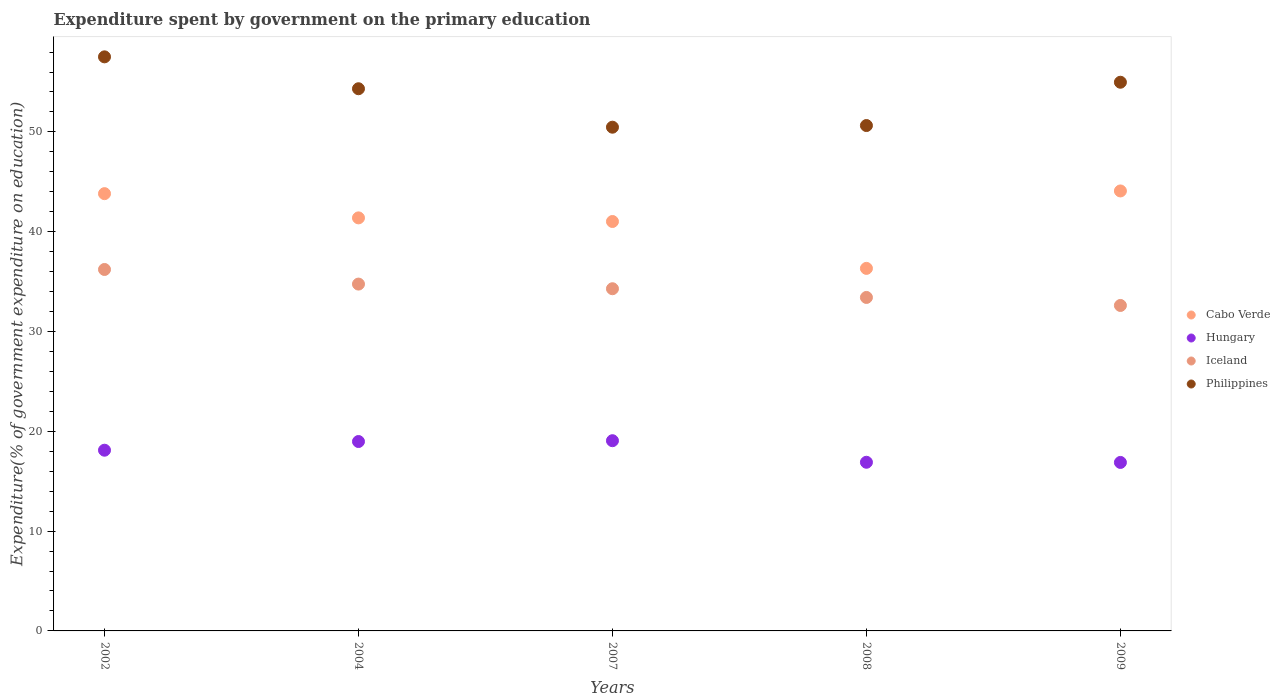How many different coloured dotlines are there?
Your answer should be very brief. 4. Is the number of dotlines equal to the number of legend labels?
Offer a very short reply. Yes. What is the expenditure spent by government on the primary education in Hungary in 2008?
Make the answer very short. 16.9. Across all years, what is the maximum expenditure spent by government on the primary education in Hungary?
Provide a succinct answer. 19.06. Across all years, what is the minimum expenditure spent by government on the primary education in Philippines?
Your answer should be compact. 50.47. In which year was the expenditure spent by government on the primary education in Cabo Verde maximum?
Provide a short and direct response. 2009. In which year was the expenditure spent by government on the primary education in Cabo Verde minimum?
Make the answer very short. 2008. What is the total expenditure spent by government on the primary education in Cabo Verde in the graph?
Give a very brief answer. 206.62. What is the difference between the expenditure spent by government on the primary education in Philippines in 2007 and that in 2009?
Make the answer very short. -4.51. What is the difference between the expenditure spent by government on the primary education in Hungary in 2002 and the expenditure spent by government on the primary education in Iceland in 2008?
Your answer should be compact. -15.31. What is the average expenditure spent by government on the primary education in Iceland per year?
Offer a very short reply. 34.25. In the year 2008, what is the difference between the expenditure spent by government on the primary education in Philippines and expenditure spent by government on the primary education in Iceland?
Your response must be concise. 17.22. What is the ratio of the expenditure spent by government on the primary education in Philippines in 2007 to that in 2008?
Ensure brevity in your answer.  1. What is the difference between the highest and the second highest expenditure spent by government on the primary education in Hungary?
Ensure brevity in your answer.  0.08. What is the difference between the highest and the lowest expenditure spent by government on the primary education in Iceland?
Keep it short and to the point. 3.61. In how many years, is the expenditure spent by government on the primary education in Cabo Verde greater than the average expenditure spent by government on the primary education in Cabo Verde taken over all years?
Your answer should be compact. 3. Is it the case that in every year, the sum of the expenditure spent by government on the primary education in Cabo Verde and expenditure spent by government on the primary education in Hungary  is greater than the sum of expenditure spent by government on the primary education in Philippines and expenditure spent by government on the primary education in Iceland?
Offer a terse response. No. Is it the case that in every year, the sum of the expenditure spent by government on the primary education in Iceland and expenditure spent by government on the primary education in Philippines  is greater than the expenditure spent by government on the primary education in Hungary?
Keep it short and to the point. Yes. Does the expenditure spent by government on the primary education in Cabo Verde monotonically increase over the years?
Make the answer very short. No. Is the expenditure spent by government on the primary education in Cabo Verde strictly less than the expenditure spent by government on the primary education in Hungary over the years?
Provide a short and direct response. No. How many dotlines are there?
Ensure brevity in your answer.  4. How many years are there in the graph?
Offer a very short reply. 5. Does the graph contain any zero values?
Your response must be concise. No. What is the title of the graph?
Keep it short and to the point. Expenditure spent by government on the primary education. What is the label or title of the Y-axis?
Offer a terse response. Expenditure(% of government expenditure on education). What is the Expenditure(% of government expenditure on education) in Cabo Verde in 2002?
Give a very brief answer. 43.81. What is the Expenditure(% of government expenditure on education) in Hungary in 2002?
Give a very brief answer. 18.11. What is the Expenditure(% of government expenditure on education) of Iceland in 2002?
Ensure brevity in your answer.  36.21. What is the Expenditure(% of government expenditure on education) in Philippines in 2002?
Provide a short and direct response. 57.52. What is the Expenditure(% of government expenditure on education) of Cabo Verde in 2004?
Provide a succinct answer. 41.38. What is the Expenditure(% of government expenditure on education) of Hungary in 2004?
Your answer should be compact. 18.98. What is the Expenditure(% of government expenditure on education) in Iceland in 2004?
Ensure brevity in your answer.  34.75. What is the Expenditure(% of government expenditure on education) in Philippines in 2004?
Keep it short and to the point. 54.32. What is the Expenditure(% of government expenditure on education) in Cabo Verde in 2007?
Your response must be concise. 41.02. What is the Expenditure(% of government expenditure on education) of Hungary in 2007?
Keep it short and to the point. 19.06. What is the Expenditure(% of government expenditure on education) of Iceland in 2007?
Provide a short and direct response. 34.29. What is the Expenditure(% of government expenditure on education) of Philippines in 2007?
Offer a terse response. 50.47. What is the Expenditure(% of government expenditure on education) of Cabo Verde in 2008?
Provide a short and direct response. 36.32. What is the Expenditure(% of government expenditure on education) in Hungary in 2008?
Provide a short and direct response. 16.9. What is the Expenditure(% of government expenditure on education) of Iceland in 2008?
Give a very brief answer. 33.41. What is the Expenditure(% of government expenditure on education) of Philippines in 2008?
Provide a short and direct response. 50.64. What is the Expenditure(% of government expenditure on education) in Cabo Verde in 2009?
Keep it short and to the point. 44.08. What is the Expenditure(% of government expenditure on education) in Hungary in 2009?
Offer a terse response. 16.88. What is the Expenditure(% of government expenditure on education) of Iceland in 2009?
Make the answer very short. 32.61. What is the Expenditure(% of government expenditure on education) in Philippines in 2009?
Offer a very short reply. 54.98. Across all years, what is the maximum Expenditure(% of government expenditure on education) in Cabo Verde?
Provide a succinct answer. 44.08. Across all years, what is the maximum Expenditure(% of government expenditure on education) of Hungary?
Your response must be concise. 19.06. Across all years, what is the maximum Expenditure(% of government expenditure on education) in Iceland?
Ensure brevity in your answer.  36.21. Across all years, what is the maximum Expenditure(% of government expenditure on education) of Philippines?
Your answer should be very brief. 57.52. Across all years, what is the minimum Expenditure(% of government expenditure on education) in Cabo Verde?
Your answer should be very brief. 36.32. Across all years, what is the minimum Expenditure(% of government expenditure on education) of Hungary?
Provide a short and direct response. 16.88. Across all years, what is the minimum Expenditure(% of government expenditure on education) of Iceland?
Offer a very short reply. 32.61. Across all years, what is the minimum Expenditure(% of government expenditure on education) in Philippines?
Your answer should be very brief. 50.47. What is the total Expenditure(% of government expenditure on education) in Cabo Verde in the graph?
Offer a very short reply. 206.62. What is the total Expenditure(% of government expenditure on education) of Hungary in the graph?
Keep it short and to the point. 89.92. What is the total Expenditure(% of government expenditure on education) of Iceland in the graph?
Offer a very short reply. 171.27. What is the total Expenditure(% of government expenditure on education) of Philippines in the graph?
Your answer should be very brief. 267.92. What is the difference between the Expenditure(% of government expenditure on education) in Cabo Verde in 2002 and that in 2004?
Offer a very short reply. 2.43. What is the difference between the Expenditure(% of government expenditure on education) of Hungary in 2002 and that in 2004?
Offer a terse response. -0.87. What is the difference between the Expenditure(% of government expenditure on education) of Iceland in 2002 and that in 2004?
Give a very brief answer. 1.46. What is the difference between the Expenditure(% of government expenditure on education) of Philippines in 2002 and that in 2004?
Ensure brevity in your answer.  3.2. What is the difference between the Expenditure(% of government expenditure on education) in Cabo Verde in 2002 and that in 2007?
Your answer should be very brief. 2.79. What is the difference between the Expenditure(% of government expenditure on education) in Hungary in 2002 and that in 2007?
Your response must be concise. -0.95. What is the difference between the Expenditure(% of government expenditure on education) of Iceland in 2002 and that in 2007?
Provide a succinct answer. 1.93. What is the difference between the Expenditure(% of government expenditure on education) of Philippines in 2002 and that in 2007?
Ensure brevity in your answer.  7.05. What is the difference between the Expenditure(% of government expenditure on education) of Cabo Verde in 2002 and that in 2008?
Offer a very short reply. 7.49. What is the difference between the Expenditure(% of government expenditure on education) of Hungary in 2002 and that in 2008?
Give a very brief answer. 1.21. What is the difference between the Expenditure(% of government expenditure on education) of Iceland in 2002 and that in 2008?
Provide a succinct answer. 2.8. What is the difference between the Expenditure(% of government expenditure on education) in Philippines in 2002 and that in 2008?
Your answer should be compact. 6.88. What is the difference between the Expenditure(% of government expenditure on education) of Cabo Verde in 2002 and that in 2009?
Ensure brevity in your answer.  -0.27. What is the difference between the Expenditure(% of government expenditure on education) of Hungary in 2002 and that in 2009?
Give a very brief answer. 1.23. What is the difference between the Expenditure(% of government expenditure on education) of Iceland in 2002 and that in 2009?
Your answer should be very brief. 3.61. What is the difference between the Expenditure(% of government expenditure on education) of Philippines in 2002 and that in 2009?
Your answer should be compact. 2.54. What is the difference between the Expenditure(% of government expenditure on education) in Cabo Verde in 2004 and that in 2007?
Keep it short and to the point. 0.36. What is the difference between the Expenditure(% of government expenditure on education) of Hungary in 2004 and that in 2007?
Keep it short and to the point. -0.08. What is the difference between the Expenditure(% of government expenditure on education) of Iceland in 2004 and that in 2007?
Your answer should be compact. 0.47. What is the difference between the Expenditure(% of government expenditure on education) in Philippines in 2004 and that in 2007?
Offer a terse response. 3.85. What is the difference between the Expenditure(% of government expenditure on education) of Cabo Verde in 2004 and that in 2008?
Provide a short and direct response. 5.06. What is the difference between the Expenditure(% of government expenditure on education) in Hungary in 2004 and that in 2008?
Give a very brief answer. 2.08. What is the difference between the Expenditure(% of government expenditure on education) in Iceland in 2004 and that in 2008?
Your response must be concise. 1.34. What is the difference between the Expenditure(% of government expenditure on education) in Philippines in 2004 and that in 2008?
Offer a very short reply. 3.69. What is the difference between the Expenditure(% of government expenditure on education) of Cabo Verde in 2004 and that in 2009?
Ensure brevity in your answer.  -2.7. What is the difference between the Expenditure(% of government expenditure on education) of Hungary in 2004 and that in 2009?
Offer a terse response. 2.1. What is the difference between the Expenditure(% of government expenditure on education) of Iceland in 2004 and that in 2009?
Provide a succinct answer. 2.14. What is the difference between the Expenditure(% of government expenditure on education) of Philippines in 2004 and that in 2009?
Provide a short and direct response. -0.65. What is the difference between the Expenditure(% of government expenditure on education) of Cabo Verde in 2007 and that in 2008?
Provide a short and direct response. 4.7. What is the difference between the Expenditure(% of government expenditure on education) of Hungary in 2007 and that in 2008?
Provide a succinct answer. 2.16. What is the difference between the Expenditure(% of government expenditure on education) in Iceland in 2007 and that in 2008?
Your answer should be compact. 0.87. What is the difference between the Expenditure(% of government expenditure on education) in Philippines in 2007 and that in 2008?
Provide a succinct answer. -0.17. What is the difference between the Expenditure(% of government expenditure on education) in Cabo Verde in 2007 and that in 2009?
Your response must be concise. -3.06. What is the difference between the Expenditure(% of government expenditure on education) of Hungary in 2007 and that in 2009?
Keep it short and to the point. 2.18. What is the difference between the Expenditure(% of government expenditure on education) of Iceland in 2007 and that in 2009?
Your response must be concise. 1.68. What is the difference between the Expenditure(% of government expenditure on education) of Philippines in 2007 and that in 2009?
Offer a terse response. -4.51. What is the difference between the Expenditure(% of government expenditure on education) in Cabo Verde in 2008 and that in 2009?
Offer a very short reply. -7.76. What is the difference between the Expenditure(% of government expenditure on education) of Hungary in 2008 and that in 2009?
Your answer should be very brief. 0.02. What is the difference between the Expenditure(% of government expenditure on education) of Iceland in 2008 and that in 2009?
Your response must be concise. 0.8. What is the difference between the Expenditure(% of government expenditure on education) in Philippines in 2008 and that in 2009?
Make the answer very short. -4.34. What is the difference between the Expenditure(% of government expenditure on education) in Cabo Verde in 2002 and the Expenditure(% of government expenditure on education) in Hungary in 2004?
Your answer should be very brief. 24.84. What is the difference between the Expenditure(% of government expenditure on education) in Cabo Verde in 2002 and the Expenditure(% of government expenditure on education) in Iceland in 2004?
Your response must be concise. 9.06. What is the difference between the Expenditure(% of government expenditure on education) in Cabo Verde in 2002 and the Expenditure(% of government expenditure on education) in Philippines in 2004?
Offer a terse response. -10.51. What is the difference between the Expenditure(% of government expenditure on education) of Hungary in 2002 and the Expenditure(% of government expenditure on education) of Iceland in 2004?
Keep it short and to the point. -16.64. What is the difference between the Expenditure(% of government expenditure on education) in Hungary in 2002 and the Expenditure(% of government expenditure on education) in Philippines in 2004?
Give a very brief answer. -36.22. What is the difference between the Expenditure(% of government expenditure on education) of Iceland in 2002 and the Expenditure(% of government expenditure on education) of Philippines in 2004?
Provide a short and direct response. -18.11. What is the difference between the Expenditure(% of government expenditure on education) in Cabo Verde in 2002 and the Expenditure(% of government expenditure on education) in Hungary in 2007?
Give a very brief answer. 24.75. What is the difference between the Expenditure(% of government expenditure on education) of Cabo Verde in 2002 and the Expenditure(% of government expenditure on education) of Iceland in 2007?
Ensure brevity in your answer.  9.53. What is the difference between the Expenditure(% of government expenditure on education) in Cabo Verde in 2002 and the Expenditure(% of government expenditure on education) in Philippines in 2007?
Offer a very short reply. -6.66. What is the difference between the Expenditure(% of government expenditure on education) of Hungary in 2002 and the Expenditure(% of government expenditure on education) of Iceland in 2007?
Your response must be concise. -16.18. What is the difference between the Expenditure(% of government expenditure on education) of Hungary in 2002 and the Expenditure(% of government expenditure on education) of Philippines in 2007?
Provide a succinct answer. -32.36. What is the difference between the Expenditure(% of government expenditure on education) in Iceland in 2002 and the Expenditure(% of government expenditure on education) in Philippines in 2007?
Make the answer very short. -14.26. What is the difference between the Expenditure(% of government expenditure on education) in Cabo Verde in 2002 and the Expenditure(% of government expenditure on education) in Hungary in 2008?
Keep it short and to the point. 26.91. What is the difference between the Expenditure(% of government expenditure on education) in Cabo Verde in 2002 and the Expenditure(% of government expenditure on education) in Iceland in 2008?
Offer a very short reply. 10.4. What is the difference between the Expenditure(% of government expenditure on education) of Cabo Verde in 2002 and the Expenditure(% of government expenditure on education) of Philippines in 2008?
Provide a succinct answer. -6.82. What is the difference between the Expenditure(% of government expenditure on education) of Hungary in 2002 and the Expenditure(% of government expenditure on education) of Iceland in 2008?
Your response must be concise. -15.31. What is the difference between the Expenditure(% of government expenditure on education) of Hungary in 2002 and the Expenditure(% of government expenditure on education) of Philippines in 2008?
Provide a succinct answer. -32.53. What is the difference between the Expenditure(% of government expenditure on education) of Iceland in 2002 and the Expenditure(% of government expenditure on education) of Philippines in 2008?
Keep it short and to the point. -14.42. What is the difference between the Expenditure(% of government expenditure on education) in Cabo Verde in 2002 and the Expenditure(% of government expenditure on education) in Hungary in 2009?
Ensure brevity in your answer.  26.93. What is the difference between the Expenditure(% of government expenditure on education) in Cabo Verde in 2002 and the Expenditure(% of government expenditure on education) in Iceland in 2009?
Ensure brevity in your answer.  11.2. What is the difference between the Expenditure(% of government expenditure on education) in Cabo Verde in 2002 and the Expenditure(% of government expenditure on education) in Philippines in 2009?
Give a very brief answer. -11.16. What is the difference between the Expenditure(% of government expenditure on education) in Hungary in 2002 and the Expenditure(% of government expenditure on education) in Iceland in 2009?
Your answer should be very brief. -14.5. What is the difference between the Expenditure(% of government expenditure on education) of Hungary in 2002 and the Expenditure(% of government expenditure on education) of Philippines in 2009?
Ensure brevity in your answer.  -36.87. What is the difference between the Expenditure(% of government expenditure on education) in Iceland in 2002 and the Expenditure(% of government expenditure on education) in Philippines in 2009?
Offer a terse response. -18.76. What is the difference between the Expenditure(% of government expenditure on education) in Cabo Verde in 2004 and the Expenditure(% of government expenditure on education) in Hungary in 2007?
Your answer should be very brief. 22.33. What is the difference between the Expenditure(% of government expenditure on education) of Cabo Verde in 2004 and the Expenditure(% of government expenditure on education) of Iceland in 2007?
Make the answer very short. 7.1. What is the difference between the Expenditure(% of government expenditure on education) in Cabo Verde in 2004 and the Expenditure(% of government expenditure on education) in Philippines in 2007?
Provide a short and direct response. -9.09. What is the difference between the Expenditure(% of government expenditure on education) of Hungary in 2004 and the Expenditure(% of government expenditure on education) of Iceland in 2007?
Ensure brevity in your answer.  -15.31. What is the difference between the Expenditure(% of government expenditure on education) of Hungary in 2004 and the Expenditure(% of government expenditure on education) of Philippines in 2007?
Keep it short and to the point. -31.49. What is the difference between the Expenditure(% of government expenditure on education) in Iceland in 2004 and the Expenditure(% of government expenditure on education) in Philippines in 2007?
Give a very brief answer. -15.72. What is the difference between the Expenditure(% of government expenditure on education) in Cabo Verde in 2004 and the Expenditure(% of government expenditure on education) in Hungary in 2008?
Your answer should be compact. 24.49. What is the difference between the Expenditure(% of government expenditure on education) of Cabo Verde in 2004 and the Expenditure(% of government expenditure on education) of Iceland in 2008?
Your response must be concise. 7.97. What is the difference between the Expenditure(% of government expenditure on education) of Cabo Verde in 2004 and the Expenditure(% of government expenditure on education) of Philippines in 2008?
Provide a short and direct response. -9.25. What is the difference between the Expenditure(% of government expenditure on education) in Hungary in 2004 and the Expenditure(% of government expenditure on education) in Iceland in 2008?
Offer a terse response. -14.44. What is the difference between the Expenditure(% of government expenditure on education) in Hungary in 2004 and the Expenditure(% of government expenditure on education) in Philippines in 2008?
Your response must be concise. -31.66. What is the difference between the Expenditure(% of government expenditure on education) in Iceland in 2004 and the Expenditure(% of government expenditure on education) in Philippines in 2008?
Make the answer very short. -15.88. What is the difference between the Expenditure(% of government expenditure on education) of Cabo Verde in 2004 and the Expenditure(% of government expenditure on education) of Hungary in 2009?
Ensure brevity in your answer.  24.5. What is the difference between the Expenditure(% of government expenditure on education) in Cabo Verde in 2004 and the Expenditure(% of government expenditure on education) in Iceland in 2009?
Provide a succinct answer. 8.78. What is the difference between the Expenditure(% of government expenditure on education) in Cabo Verde in 2004 and the Expenditure(% of government expenditure on education) in Philippines in 2009?
Your response must be concise. -13.59. What is the difference between the Expenditure(% of government expenditure on education) of Hungary in 2004 and the Expenditure(% of government expenditure on education) of Iceland in 2009?
Your response must be concise. -13.63. What is the difference between the Expenditure(% of government expenditure on education) in Hungary in 2004 and the Expenditure(% of government expenditure on education) in Philippines in 2009?
Ensure brevity in your answer.  -36. What is the difference between the Expenditure(% of government expenditure on education) of Iceland in 2004 and the Expenditure(% of government expenditure on education) of Philippines in 2009?
Offer a very short reply. -20.22. What is the difference between the Expenditure(% of government expenditure on education) in Cabo Verde in 2007 and the Expenditure(% of government expenditure on education) in Hungary in 2008?
Provide a succinct answer. 24.12. What is the difference between the Expenditure(% of government expenditure on education) in Cabo Verde in 2007 and the Expenditure(% of government expenditure on education) in Iceland in 2008?
Make the answer very short. 7.61. What is the difference between the Expenditure(% of government expenditure on education) in Cabo Verde in 2007 and the Expenditure(% of government expenditure on education) in Philippines in 2008?
Offer a very short reply. -9.61. What is the difference between the Expenditure(% of government expenditure on education) in Hungary in 2007 and the Expenditure(% of government expenditure on education) in Iceland in 2008?
Give a very brief answer. -14.35. What is the difference between the Expenditure(% of government expenditure on education) in Hungary in 2007 and the Expenditure(% of government expenditure on education) in Philippines in 2008?
Your answer should be very brief. -31.58. What is the difference between the Expenditure(% of government expenditure on education) of Iceland in 2007 and the Expenditure(% of government expenditure on education) of Philippines in 2008?
Provide a short and direct response. -16.35. What is the difference between the Expenditure(% of government expenditure on education) in Cabo Verde in 2007 and the Expenditure(% of government expenditure on education) in Hungary in 2009?
Offer a very short reply. 24.14. What is the difference between the Expenditure(% of government expenditure on education) in Cabo Verde in 2007 and the Expenditure(% of government expenditure on education) in Iceland in 2009?
Make the answer very short. 8.41. What is the difference between the Expenditure(% of government expenditure on education) of Cabo Verde in 2007 and the Expenditure(% of government expenditure on education) of Philippines in 2009?
Ensure brevity in your answer.  -13.95. What is the difference between the Expenditure(% of government expenditure on education) of Hungary in 2007 and the Expenditure(% of government expenditure on education) of Iceland in 2009?
Make the answer very short. -13.55. What is the difference between the Expenditure(% of government expenditure on education) of Hungary in 2007 and the Expenditure(% of government expenditure on education) of Philippines in 2009?
Offer a very short reply. -35.92. What is the difference between the Expenditure(% of government expenditure on education) of Iceland in 2007 and the Expenditure(% of government expenditure on education) of Philippines in 2009?
Provide a succinct answer. -20.69. What is the difference between the Expenditure(% of government expenditure on education) of Cabo Verde in 2008 and the Expenditure(% of government expenditure on education) of Hungary in 2009?
Offer a very short reply. 19.44. What is the difference between the Expenditure(% of government expenditure on education) in Cabo Verde in 2008 and the Expenditure(% of government expenditure on education) in Iceland in 2009?
Your response must be concise. 3.72. What is the difference between the Expenditure(% of government expenditure on education) in Cabo Verde in 2008 and the Expenditure(% of government expenditure on education) in Philippines in 2009?
Provide a succinct answer. -18.65. What is the difference between the Expenditure(% of government expenditure on education) in Hungary in 2008 and the Expenditure(% of government expenditure on education) in Iceland in 2009?
Your answer should be very brief. -15.71. What is the difference between the Expenditure(% of government expenditure on education) of Hungary in 2008 and the Expenditure(% of government expenditure on education) of Philippines in 2009?
Your answer should be compact. -38.08. What is the difference between the Expenditure(% of government expenditure on education) of Iceland in 2008 and the Expenditure(% of government expenditure on education) of Philippines in 2009?
Offer a very short reply. -21.56. What is the average Expenditure(% of government expenditure on education) in Cabo Verde per year?
Offer a terse response. 41.32. What is the average Expenditure(% of government expenditure on education) of Hungary per year?
Your answer should be very brief. 17.98. What is the average Expenditure(% of government expenditure on education) in Iceland per year?
Give a very brief answer. 34.25. What is the average Expenditure(% of government expenditure on education) in Philippines per year?
Ensure brevity in your answer.  53.58. In the year 2002, what is the difference between the Expenditure(% of government expenditure on education) of Cabo Verde and Expenditure(% of government expenditure on education) of Hungary?
Give a very brief answer. 25.71. In the year 2002, what is the difference between the Expenditure(% of government expenditure on education) in Cabo Verde and Expenditure(% of government expenditure on education) in Iceland?
Make the answer very short. 7.6. In the year 2002, what is the difference between the Expenditure(% of government expenditure on education) of Cabo Verde and Expenditure(% of government expenditure on education) of Philippines?
Provide a succinct answer. -13.71. In the year 2002, what is the difference between the Expenditure(% of government expenditure on education) of Hungary and Expenditure(% of government expenditure on education) of Iceland?
Offer a terse response. -18.11. In the year 2002, what is the difference between the Expenditure(% of government expenditure on education) of Hungary and Expenditure(% of government expenditure on education) of Philippines?
Your answer should be compact. -39.41. In the year 2002, what is the difference between the Expenditure(% of government expenditure on education) of Iceland and Expenditure(% of government expenditure on education) of Philippines?
Offer a terse response. -21.3. In the year 2004, what is the difference between the Expenditure(% of government expenditure on education) of Cabo Verde and Expenditure(% of government expenditure on education) of Hungary?
Your answer should be very brief. 22.41. In the year 2004, what is the difference between the Expenditure(% of government expenditure on education) in Cabo Verde and Expenditure(% of government expenditure on education) in Iceland?
Ensure brevity in your answer.  6.63. In the year 2004, what is the difference between the Expenditure(% of government expenditure on education) of Cabo Verde and Expenditure(% of government expenditure on education) of Philippines?
Provide a short and direct response. -12.94. In the year 2004, what is the difference between the Expenditure(% of government expenditure on education) of Hungary and Expenditure(% of government expenditure on education) of Iceland?
Make the answer very short. -15.77. In the year 2004, what is the difference between the Expenditure(% of government expenditure on education) of Hungary and Expenditure(% of government expenditure on education) of Philippines?
Make the answer very short. -35.35. In the year 2004, what is the difference between the Expenditure(% of government expenditure on education) in Iceland and Expenditure(% of government expenditure on education) in Philippines?
Offer a terse response. -19.57. In the year 2007, what is the difference between the Expenditure(% of government expenditure on education) of Cabo Verde and Expenditure(% of government expenditure on education) of Hungary?
Ensure brevity in your answer.  21.96. In the year 2007, what is the difference between the Expenditure(% of government expenditure on education) in Cabo Verde and Expenditure(% of government expenditure on education) in Iceland?
Offer a very short reply. 6.74. In the year 2007, what is the difference between the Expenditure(% of government expenditure on education) in Cabo Verde and Expenditure(% of government expenditure on education) in Philippines?
Provide a succinct answer. -9.45. In the year 2007, what is the difference between the Expenditure(% of government expenditure on education) in Hungary and Expenditure(% of government expenditure on education) in Iceland?
Your answer should be very brief. -15.23. In the year 2007, what is the difference between the Expenditure(% of government expenditure on education) of Hungary and Expenditure(% of government expenditure on education) of Philippines?
Keep it short and to the point. -31.41. In the year 2007, what is the difference between the Expenditure(% of government expenditure on education) of Iceland and Expenditure(% of government expenditure on education) of Philippines?
Make the answer very short. -16.18. In the year 2008, what is the difference between the Expenditure(% of government expenditure on education) in Cabo Verde and Expenditure(% of government expenditure on education) in Hungary?
Your answer should be compact. 19.43. In the year 2008, what is the difference between the Expenditure(% of government expenditure on education) of Cabo Verde and Expenditure(% of government expenditure on education) of Iceland?
Offer a very short reply. 2.91. In the year 2008, what is the difference between the Expenditure(% of government expenditure on education) of Cabo Verde and Expenditure(% of government expenditure on education) of Philippines?
Your response must be concise. -14.31. In the year 2008, what is the difference between the Expenditure(% of government expenditure on education) of Hungary and Expenditure(% of government expenditure on education) of Iceland?
Your response must be concise. -16.51. In the year 2008, what is the difference between the Expenditure(% of government expenditure on education) in Hungary and Expenditure(% of government expenditure on education) in Philippines?
Your response must be concise. -33.74. In the year 2008, what is the difference between the Expenditure(% of government expenditure on education) of Iceland and Expenditure(% of government expenditure on education) of Philippines?
Offer a very short reply. -17.22. In the year 2009, what is the difference between the Expenditure(% of government expenditure on education) in Cabo Verde and Expenditure(% of government expenditure on education) in Hungary?
Give a very brief answer. 27.2. In the year 2009, what is the difference between the Expenditure(% of government expenditure on education) of Cabo Verde and Expenditure(% of government expenditure on education) of Iceland?
Your answer should be compact. 11.47. In the year 2009, what is the difference between the Expenditure(% of government expenditure on education) of Cabo Verde and Expenditure(% of government expenditure on education) of Philippines?
Provide a succinct answer. -10.89. In the year 2009, what is the difference between the Expenditure(% of government expenditure on education) in Hungary and Expenditure(% of government expenditure on education) in Iceland?
Keep it short and to the point. -15.73. In the year 2009, what is the difference between the Expenditure(% of government expenditure on education) in Hungary and Expenditure(% of government expenditure on education) in Philippines?
Your answer should be very brief. -38.09. In the year 2009, what is the difference between the Expenditure(% of government expenditure on education) of Iceland and Expenditure(% of government expenditure on education) of Philippines?
Your answer should be compact. -22.37. What is the ratio of the Expenditure(% of government expenditure on education) of Cabo Verde in 2002 to that in 2004?
Make the answer very short. 1.06. What is the ratio of the Expenditure(% of government expenditure on education) of Hungary in 2002 to that in 2004?
Offer a very short reply. 0.95. What is the ratio of the Expenditure(% of government expenditure on education) of Iceland in 2002 to that in 2004?
Provide a succinct answer. 1.04. What is the ratio of the Expenditure(% of government expenditure on education) of Philippines in 2002 to that in 2004?
Your answer should be very brief. 1.06. What is the ratio of the Expenditure(% of government expenditure on education) in Cabo Verde in 2002 to that in 2007?
Your response must be concise. 1.07. What is the ratio of the Expenditure(% of government expenditure on education) in Hungary in 2002 to that in 2007?
Make the answer very short. 0.95. What is the ratio of the Expenditure(% of government expenditure on education) of Iceland in 2002 to that in 2007?
Your answer should be compact. 1.06. What is the ratio of the Expenditure(% of government expenditure on education) of Philippines in 2002 to that in 2007?
Your answer should be compact. 1.14. What is the ratio of the Expenditure(% of government expenditure on education) in Cabo Verde in 2002 to that in 2008?
Offer a terse response. 1.21. What is the ratio of the Expenditure(% of government expenditure on education) of Hungary in 2002 to that in 2008?
Keep it short and to the point. 1.07. What is the ratio of the Expenditure(% of government expenditure on education) of Iceland in 2002 to that in 2008?
Your answer should be compact. 1.08. What is the ratio of the Expenditure(% of government expenditure on education) of Philippines in 2002 to that in 2008?
Make the answer very short. 1.14. What is the ratio of the Expenditure(% of government expenditure on education) in Hungary in 2002 to that in 2009?
Ensure brevity in your answer.  1.07. What is the ratio of the Expenditure(% of government expenditure on education) in Iceland in 2002 to that in 2009?
Make the answer very short. 1.11. What is the ratio of the Expenditure(% of government expenditure on education) of Philippines in 2002 to that in 2009?
Make the answer very short. 1.05. What is the ratio of the Expenditure(% of government expenditure on education) in Cabo Verde in 2004 to that in 2007?
Your response must be concise. 1.01. What is the ratio of the Expenditure(% of government expenditure on education) in Iceland in 2004 to that in 2007?
Offer a very short reply. 1.01. What is the ratio of the Expenditure(% of government expenditure on education) of Philippines in 2004 to that in 2007?
Provide a succinct answer. 1.08. What is the ratio of the Expenditure(% of government expenditure on education) of Cabo Verde in 2004 to that in 2008?
Your answer should be compact. 1.14. What is the ratio of the Expenditure(% of government expenditure on education) in Hungary in 2004 to that in 2008?
Ensure brevity in your answer.  1.12. What is the ratio of the Expenditure(% of government expenditure on education) of Iceland in 2004 to that in 2008?
Offer a very short reply. 1.04. What is the ratio of the Expenditure(% of government expenditure on education) of Philippines in 2004 to that in 2008?
Offer a terse response. 1.07. What is the ratio of the Expenditure(% of government expenditure on education) in Cabo Verde in 2004 to that in 2009?
Your response must be concise. 0.94. What is the ratio of the Expenditure(% of government expenditure on education) of Hungary in 2004 to that in 2009?
Offer a very short reply. 1.12. What is the ratio of the Expenditure(% of government expenditure on education) of Iceland in 2004 to that in 2009?
Provide a short and direct response. 1.07. What is the ratio of the Expenditure(% of government expenditure on education) of Cabo Verde in 2007 to that in 2008?
Provide a short and direct response. 1.13. What is the ratio of the Expenditure(% of government expenditure on education) of Hungary in 2007 to that in 2008?
Offer a terse response. 1.13. What is the ratio of the Expenditure(% of government expenditure on education) of Iceland in 2007 to that in 2008?
Your answer should be compact. 1.03. What is the ratio of the Expenditure(% of government expenditure on education) of Cabo Verde in 2007 to that in 2009?
Your response must be concise. 0.93. What is the ratio of the Expenditure(% of government expenditure on education) in Hungary in 2007 to that in 2009?
Offer a terse response. 1.13. What is the ratio of the Expenditure(% of government expenditure on education) of Iceland in 2007 to that in 2009?
Make the answer very short. 1.05. What is the ratio of the Expenditure(% of government expenditure on education) of Philippines in 2007 to that in 2009?
Ensure brevity in your answer.  0.92. What is the ratio of the Expenditure(% of government expenditure on education) in Cabo Verde in 2008 to that in 2009?
Keep it short and to the point. 0.82. What is the ratio of the Expenditure(% of government expenditure on education) in Iceland in 2008 to that in 2009?
Give a very brief answer. 1.02. What is the ratio of the Expenditure(% of government expenditure on education) of Philippines in 2008 to that in 2009?
Provide a short and direct response. 0.92. What is the difference between the highest and the second highest Expenditure(% of government expenditure on education) in Cabo Verde?
Make the answer very short. 0.27. What is the difference between the highest and the second highest Expenditure(% of government expenditure on education) of Hungary?
Make the answer very short. 0.08. What is the difference between the highest and the second highest Expenditure(% of government expenditure on education) in Iceland?
Offer a terse response. 1.46. What is the difference between the highest and the second highest Expenditure(% of government expenditure on education) of Philippines?
Your answer should be very brief. 2.54. What is the difference between the highest and the lowest Expenditure(% of government expenditure on education) in Cabo Verde?
Give a very brief answer. 7.76. What is the difference between the highest and the lowest Expenditure(% of government expenditure on education) in Hungary?
Offer a very short reply. 2.18. What is the difference between the highest and the lowest Expenditure(% of government expenditure on education) in Iceland?
Make the answer very short. 3.61. What is the difference between the highest and the lowest Expenditure(% of government expenditure on education) in Philippines?
Keep it short and to the point. 7.05. 